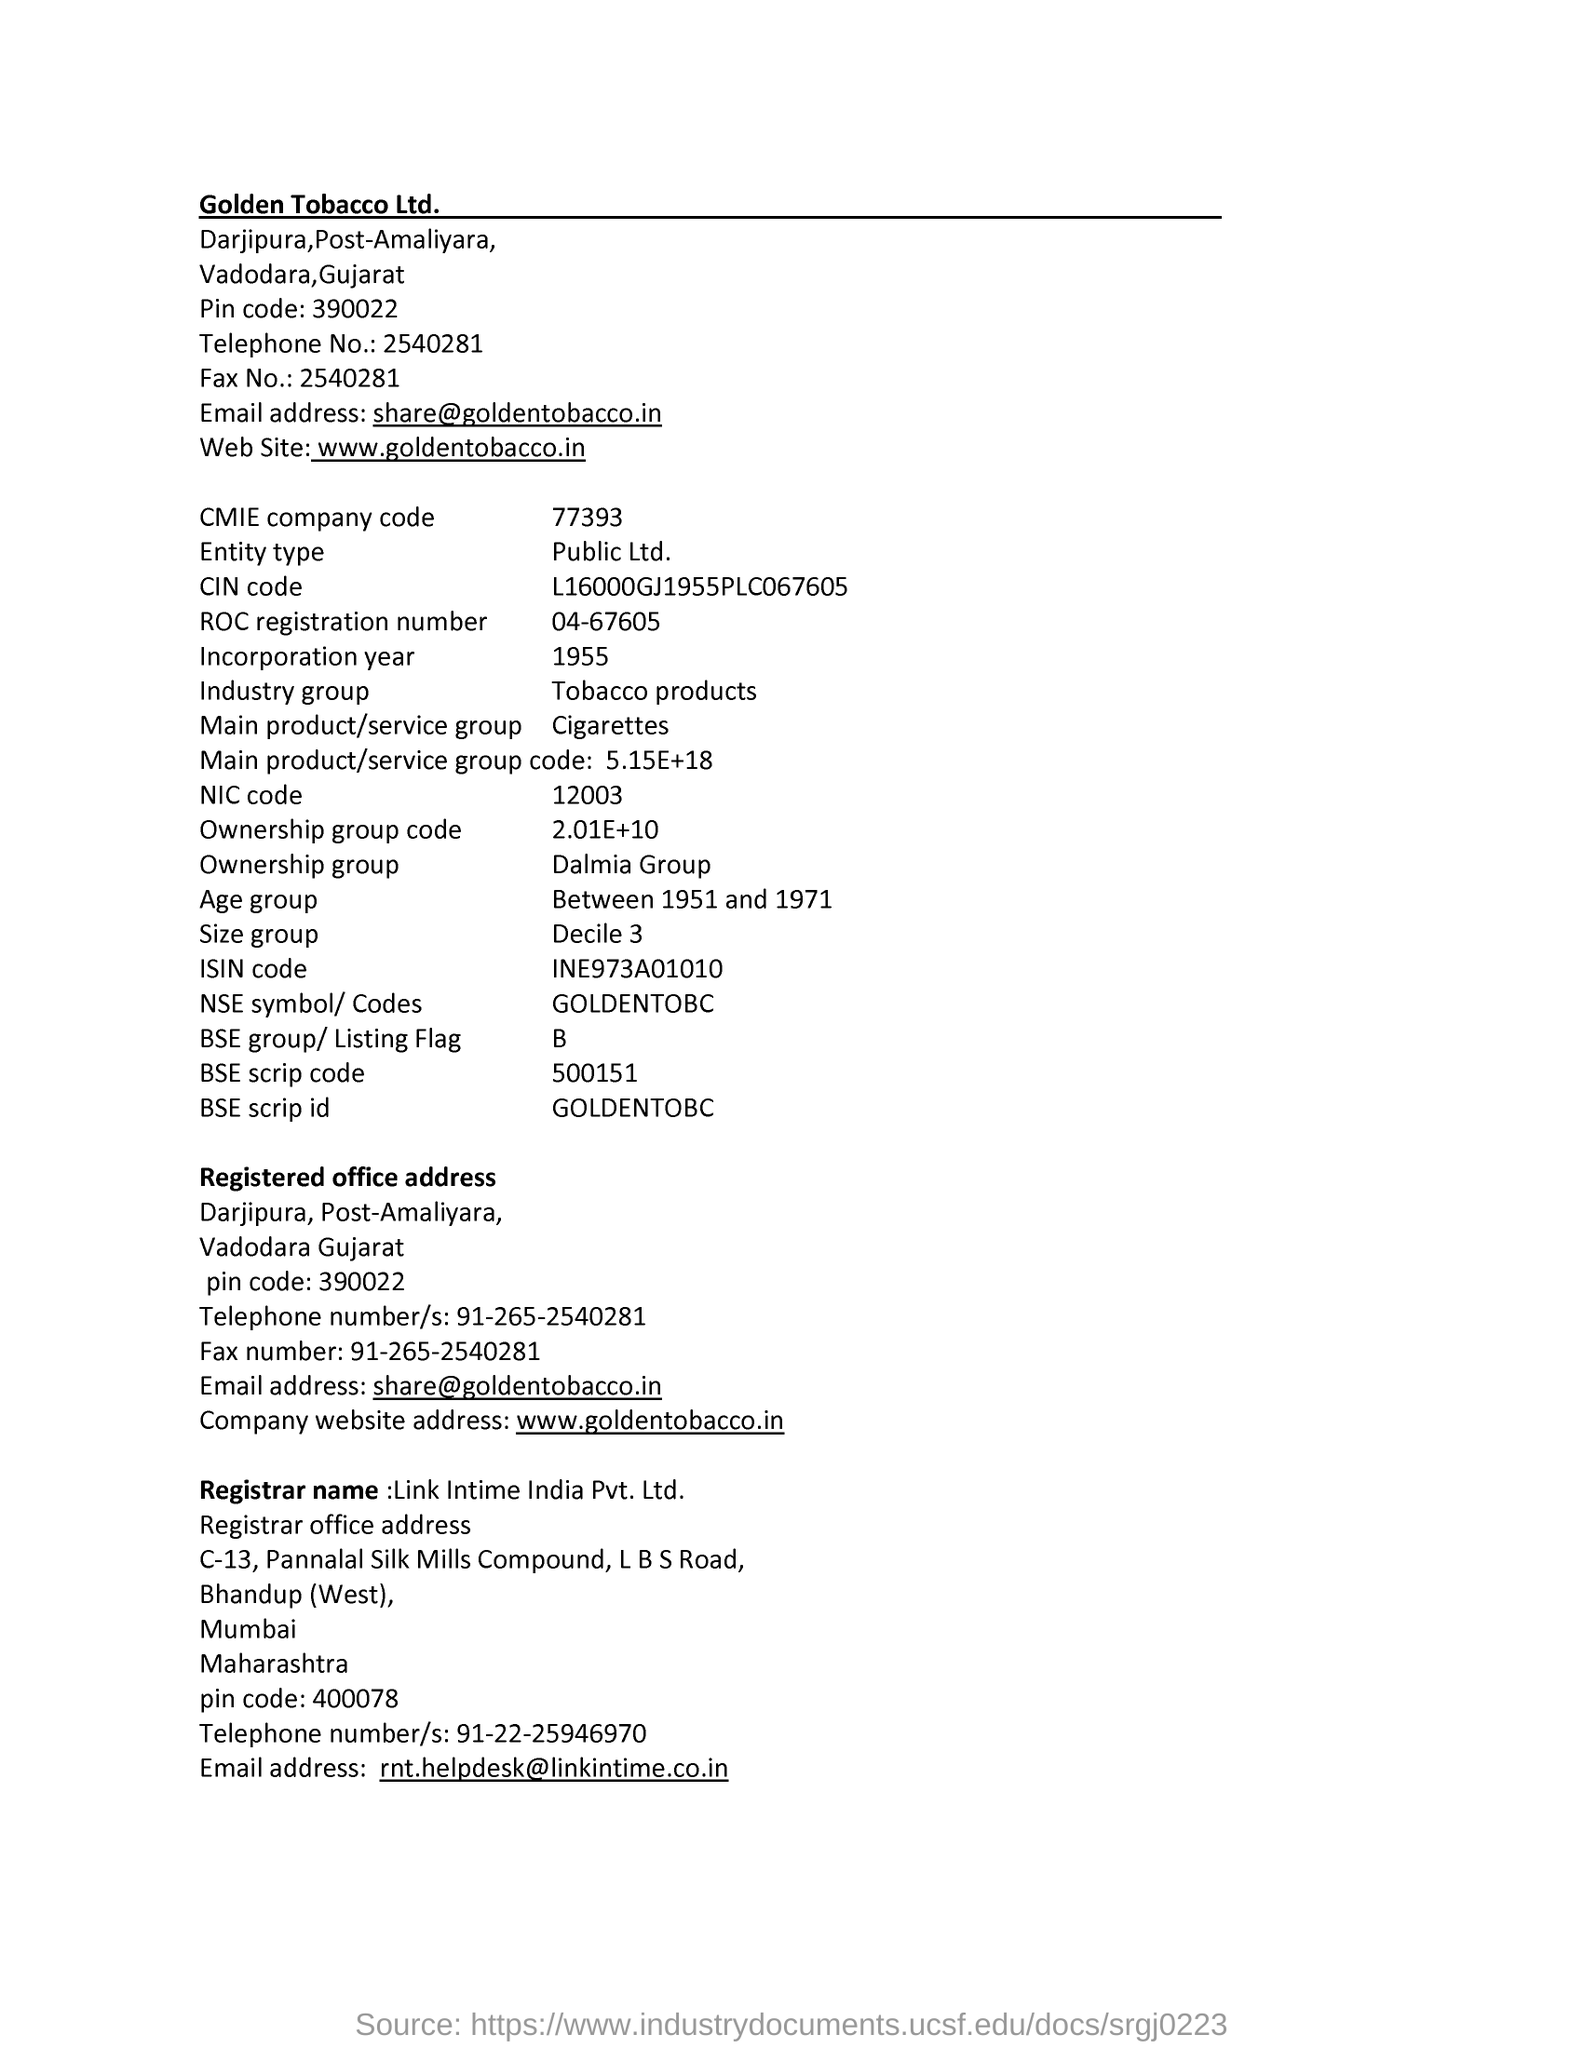Specify some key components in this picture. The CMIE company code is a unique identifier assigned to companies for the purposes of tracking and analyzing business activity. The code consists of seven digits, with the first three digits representing the company's industry classification and the remaining four digits serving as a unique identifier for that specific company. The entity type of a company is classified as "Public Limited The email address of Golden Tobacco Company is [share@goldentobacco.in](mailto:share@goldentobacco.in). I am requesting to determine the year of incorporation from a specific page. The year provided is 1955. 